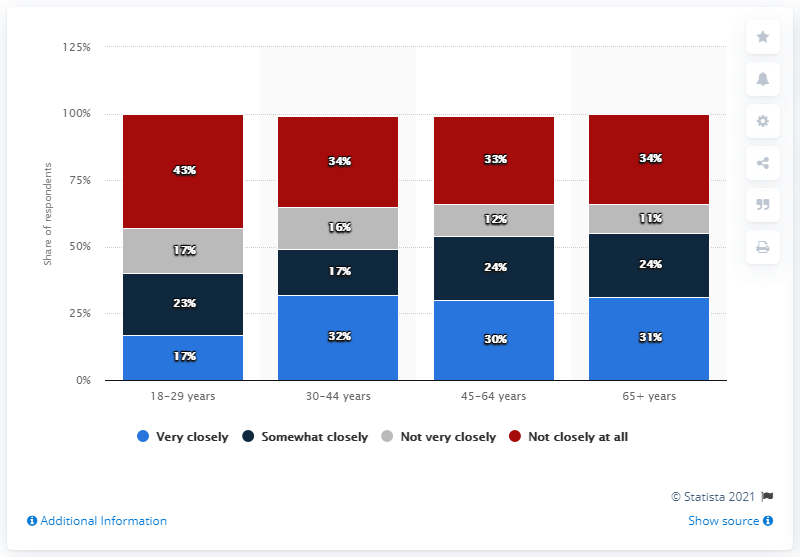List a handful of essential elements in this visual. In the National Football League, the difference in responses between those aged 30-44 who are very closed to those who are not very closed is 16%. The percentage of very closed respondents in the National Football League among those aged 30 to 44 is 32%. 